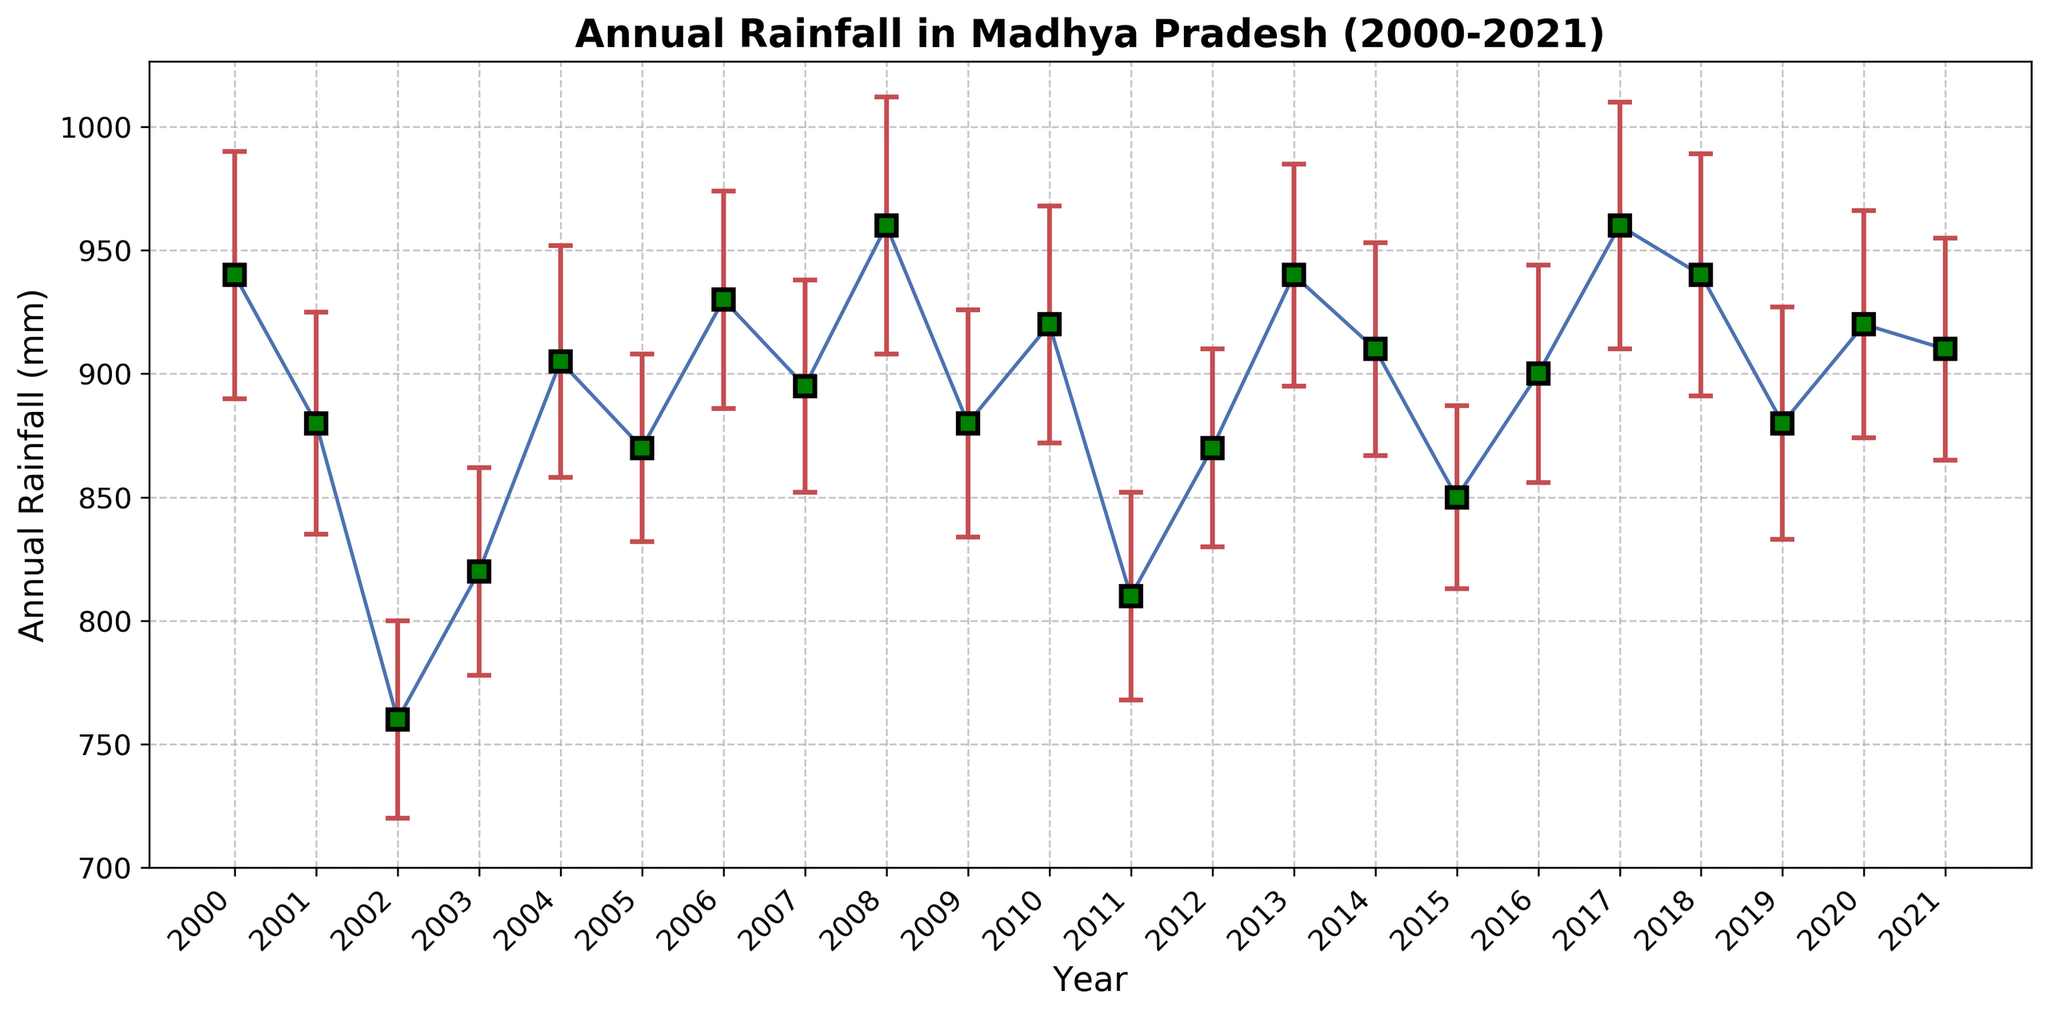Which year had the highest annual rainfall? Look at the plot and find the year with the tallest data point. The tallest data point corresponds to 2008 and 2017, each with 960 mm. To pinpoint the exact year, observe the horizontal axis labels corresponding to the tallest points.
Answer: 2008 and 2017 What is the average annual rainfall from 2000 to 2021? Add the annual rainfall values for each year and divide by the number of years. The sum of the rainfall values is (940 + 880 + 760 + 820 + 905 + 870 + 930 + 895 + 960 + 880 + 920 + 810 + 870 + 940 + 910 + 850 + 900 + 960 + 940 + 880 + 920 + 910) = 19310 mm. There are 22 years, so the average is 19310 / 22.
Answer: 878.6 mm In which years did the measurement uncertainty exceed 45 mm? Look at the error bars and identify years when they extend more than 45 mm vertically. This corresponds to the years with larger red error bars. Specifically, these years are 2000, 2008, 2010, 2017, 2018, and 2020-2021.
Answer: 2000, 2008, 2010, 2017, 2018, 2020, 2021 Was there an overall increase or decrease in annual rainfall between 2000 and 2021? Compare the annual rainfall for the first year (2000) and the last year (2021). The rainfall starts at 940 mm in 2000 and ends at 910 mm in 2021, showing a decrease of 30 mm.
Answer: Decrease What is the range of annual rainfall values observed from 2000 to 2021? Find the minimum and maximum annual rainfall values in the dataset. The lowest value is 760 mm (2002) and the highest is 960 mm (2008 and 2017). The range is calculated as the difference between these values, 960 - 760.
Answer: 200 mm How does the annual rainfall in 2011 compare to that in 2013? Compare the heights of the data points for 2011 and 2013. In 2011, the annual rainfall was 810 mm, and in 2013, it was 940 mm. 940 mm - 810 mm = 130 mm more rainfall in 2013 compared to 2011.
Answer: 130 mm more in 2013 What is the median annual rainfall from 2000 to 2021? First, arrange the annual rainfall values in ascending order: 760, 810, 820, 850, 870, 870, 870, 880, 880, 880, 895, 900, 905, 910, 910, 920, 920, 930, 940, 940, 940, 960. With 22 data points, the median is the average of the 11th and 12th values. The 11th value is 895 mm, and the 12th value is 900 mm. Their average is (895 + 900) / 2.
Answer: 897.5 mm 